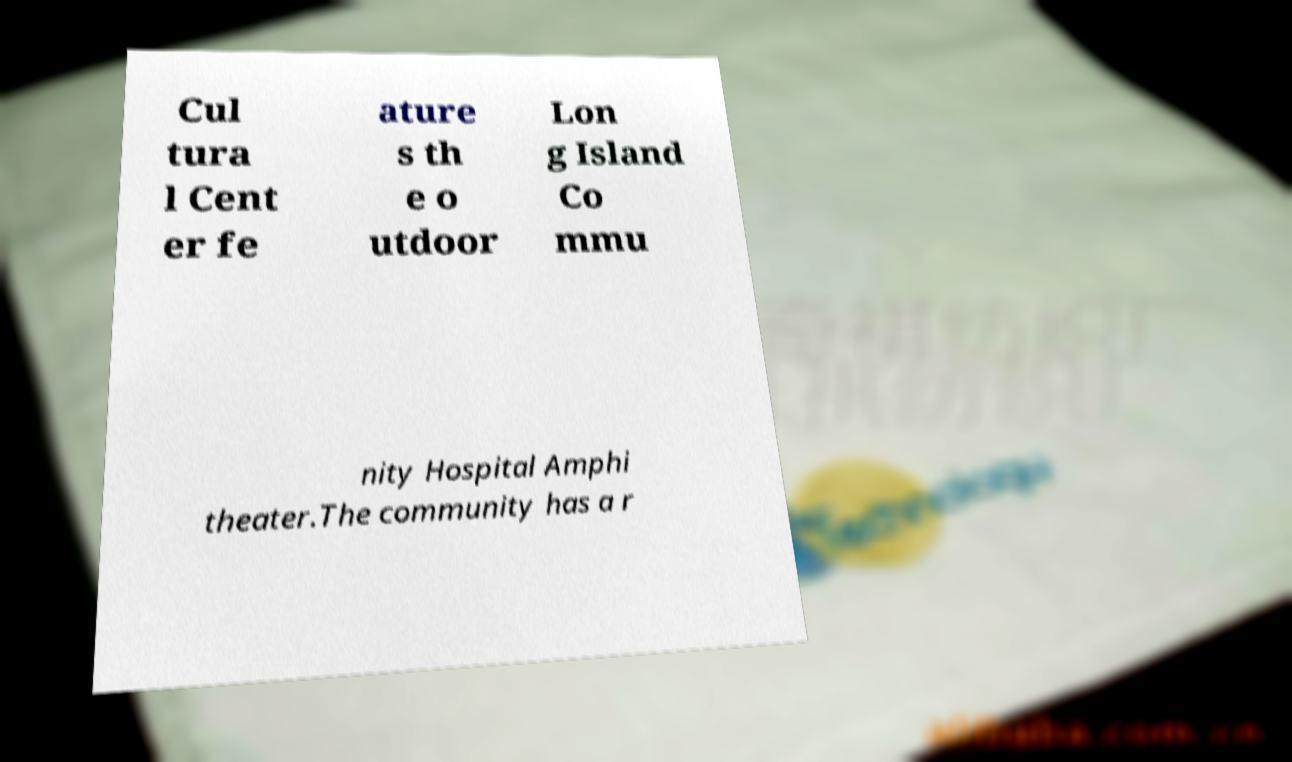Please read and relay the text visible in this image. What does it say? Cul tura l Cent er fe ature s th e o utdoor Lon g Island Co mmu nity Hospital Amphi theater.The community has a r 